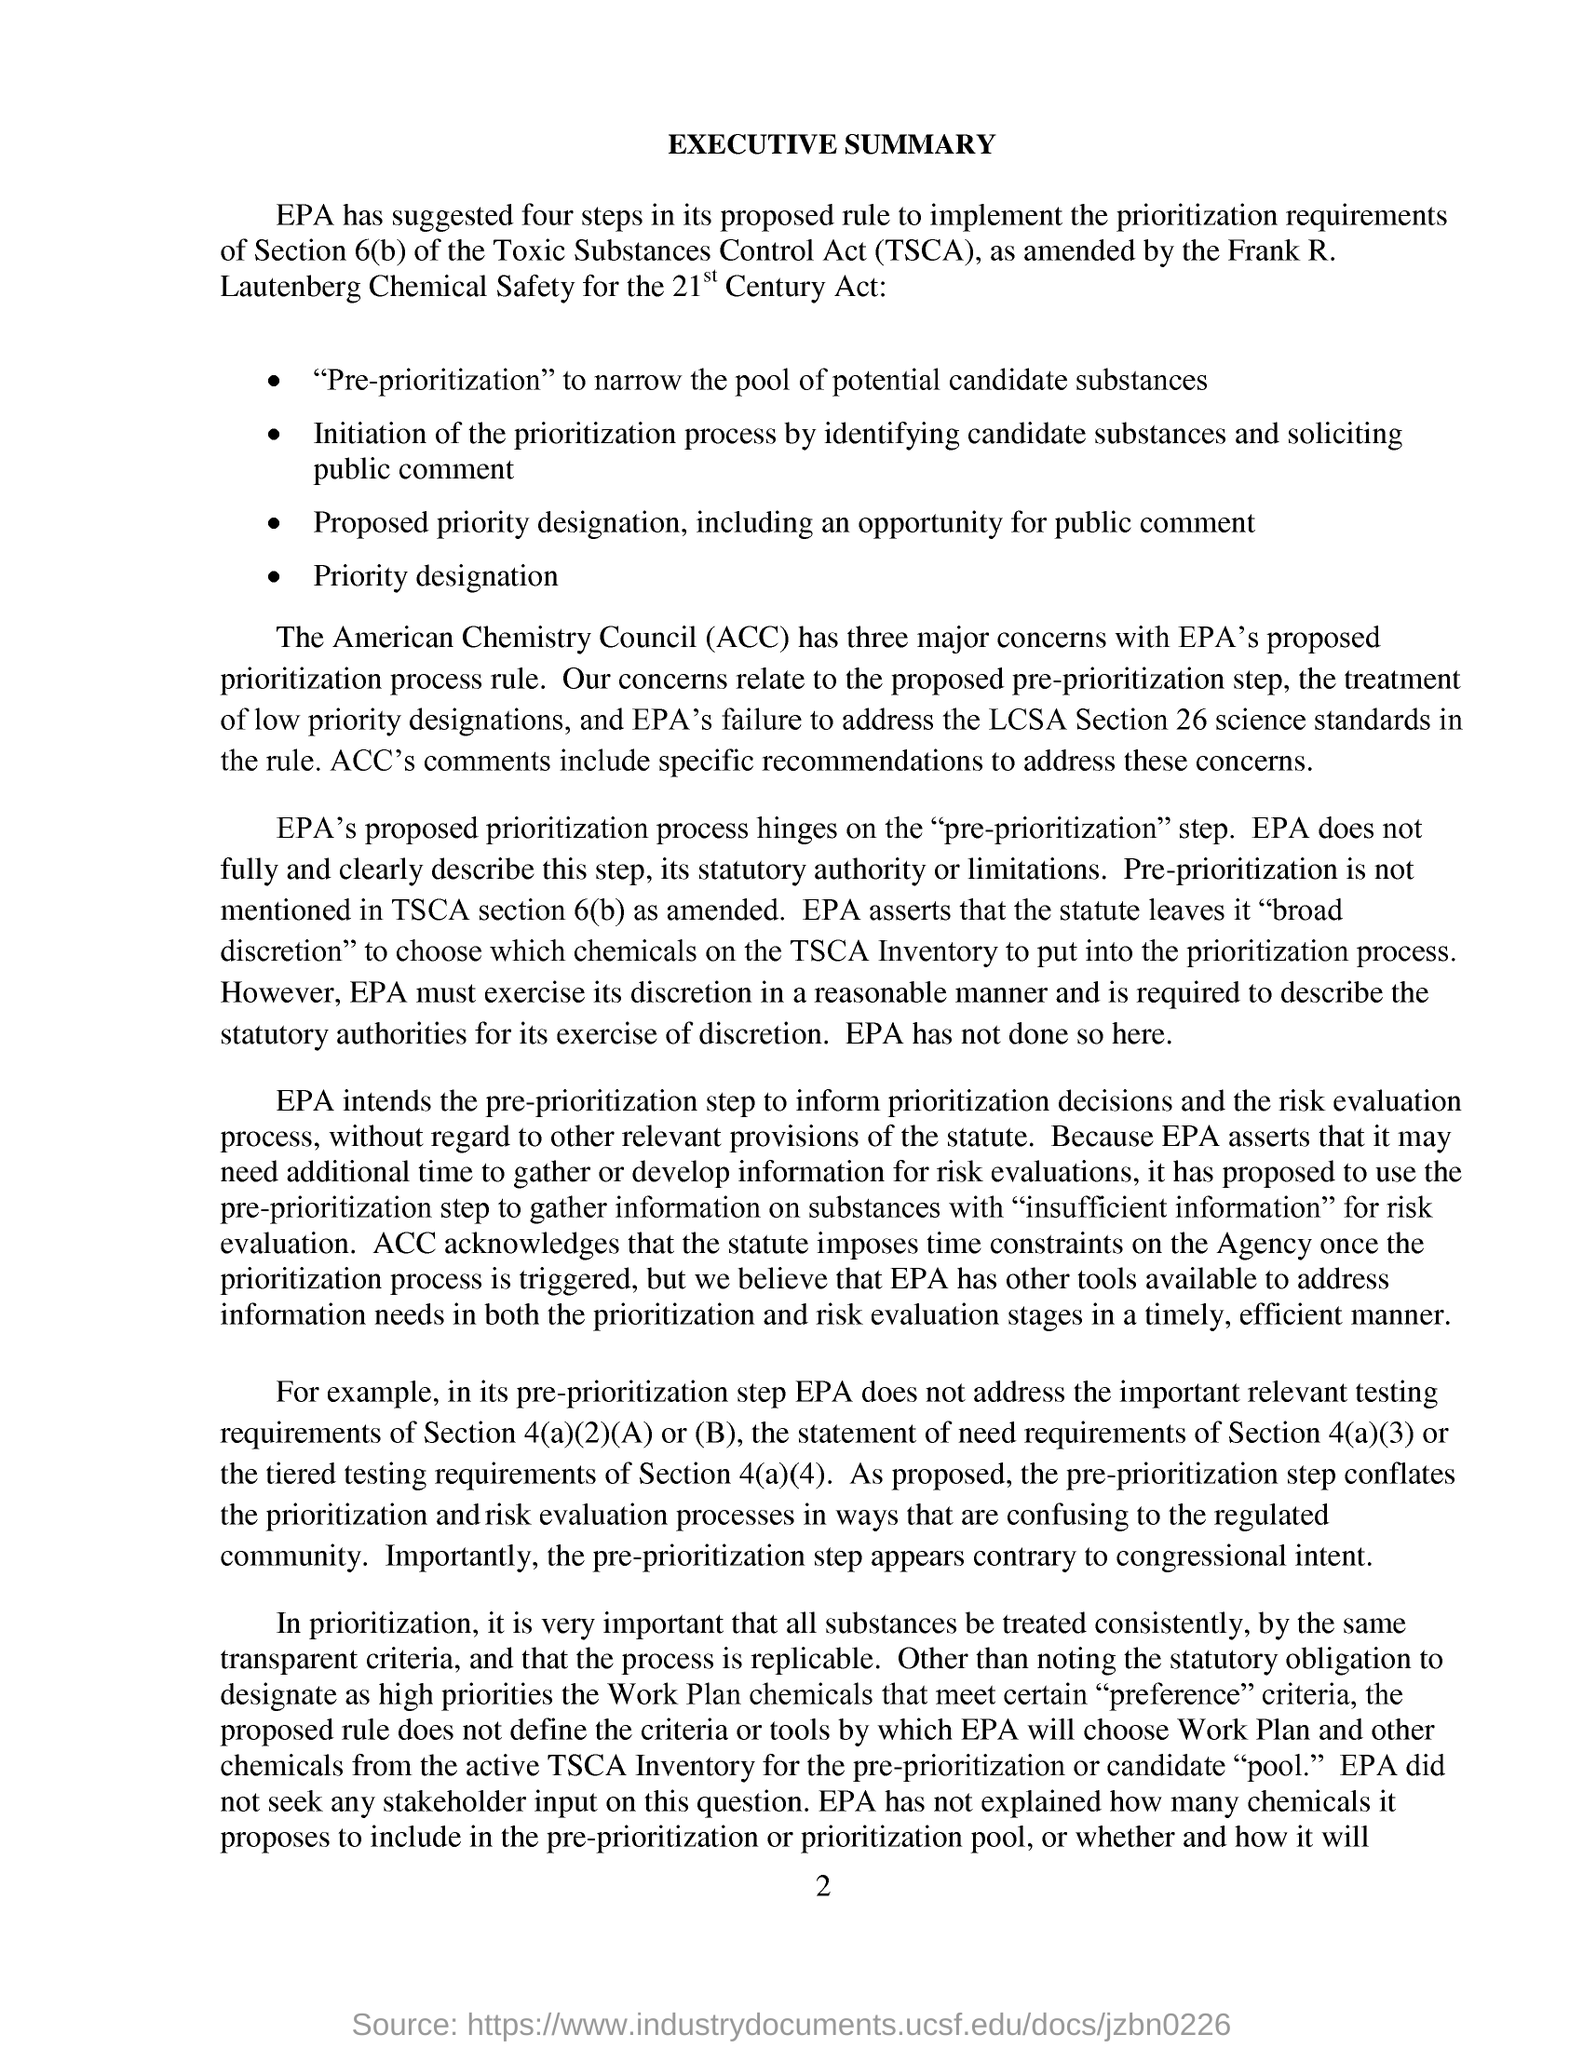What is the document heading?
Offer a terse response. Executive Summary. What is the abbreviation of 'Toxic Substances Control Act'?
Your response must be concise. TSCA. What is the fourth step suggested by EPA in its proposed rule?
Provide a short and direct response. Priority designation. What is ACC?
Your answer should be compact. American Chemistry Council. What is the page number given at the footer?
Provide a succinct answer. 2. How many steps have suggested by EPA in its proposed rule?
Your response must be concise. Four steps. 